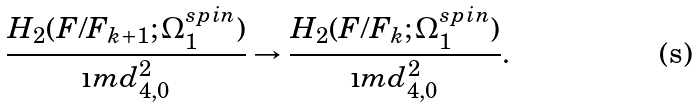<formula> <loc_0><loc_0><loc_500><loc_500>\frac { H _ { 2 } ( F / F _ { k + 1 } ; \Omega _ { 1 } ^ { s p i n } ) } { \i m d _ { 4 , 0 } ^ { 2 } } \rightarrow \frac { H _ { 2 } ( F / F _ { k } ; \Omega _ { 1 } ^ { s p i n } ) } { \i m d _ { 4 , 0 } ^ { 2 } } .</formula> 